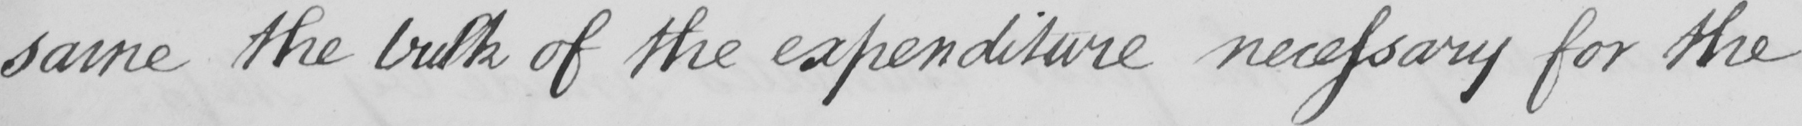Please provide the text content of this handwritten line. same the bulk of the expenditure necessary for the 